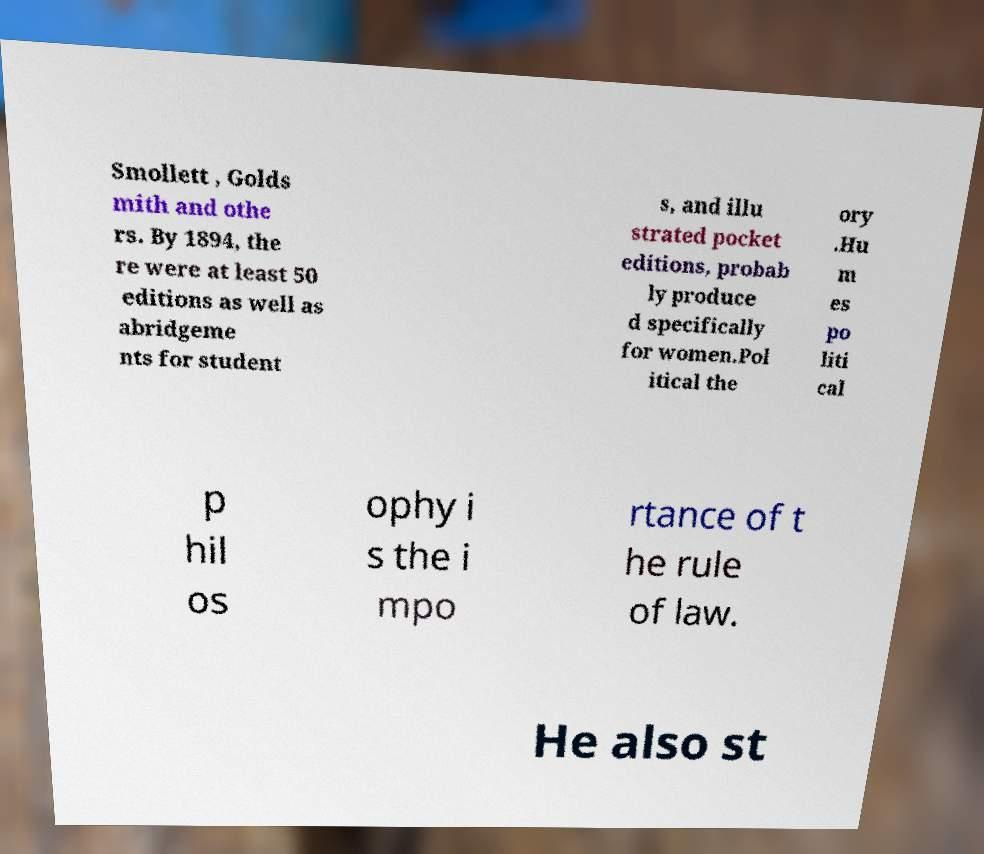There's text embedded in this image that I need extracted. Can you transcribe it verbatim? Smollett , Golds mith and othe rs. By 1894, the re were at least 50 editions as well as abridgeme nts for student s, and illu strated pocket editions, probab ly produce d specifically for women.Pol itical the ory .Hu m es po liti cal p hil os ophy i s the i mpo rtance of t he rule of law. He also st 